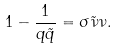<formula> <loc_0><loc_0><loc_500><loc_500>1 - \frac { 1 } { q \tilde { q } } = \sigma \tilde { \nu } \nu .</formula> 